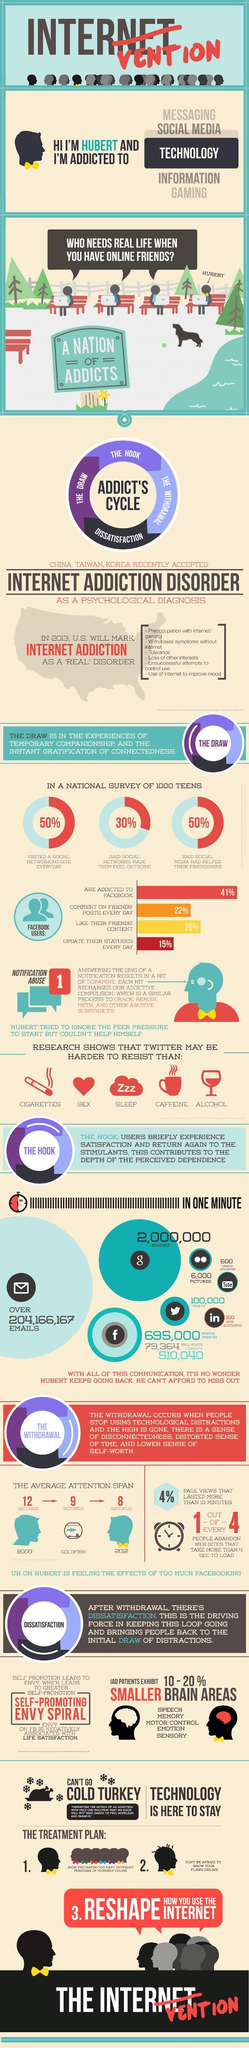What percentage of facebook users update their statuses everyday as per the survey?
Answer the question with a short phrase. 15% How many facebook comments were posted in a minute according to the survey? 510,040 What percentage of the teens said that social media had helped their friendships in a national survey of 1000 teens? 50% What is the number of  the google searches done in one minute according to the survey? 2,000,000 SEARCHES What percentage of the teens said that social networks made them feel outgoing in a national survey of 1000 teens? 30% How many new accounts were made in Linkedin in every minute as per the survey? 100 How many youtube videos are uploaded in every minute as per the survey? 600 What is the average attention span of humans in 2012? 8 SECONDS 